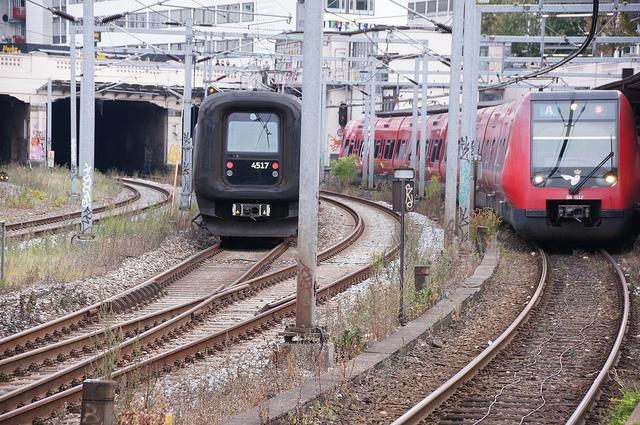The trains have what safety feature on the glass to help see visibly in stormy weather? Please explain your reasoning. windshield wipers. When it rains the drops can stay on the windshield.  it can be hard to see through them if they are not wiped away. 